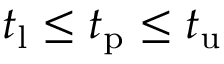Convert formula to latex. <formula><loc_0><loc_0><loc_500><loc_500>t _ { l } \leq t _ { p } \leq t _ { u }</formula> 